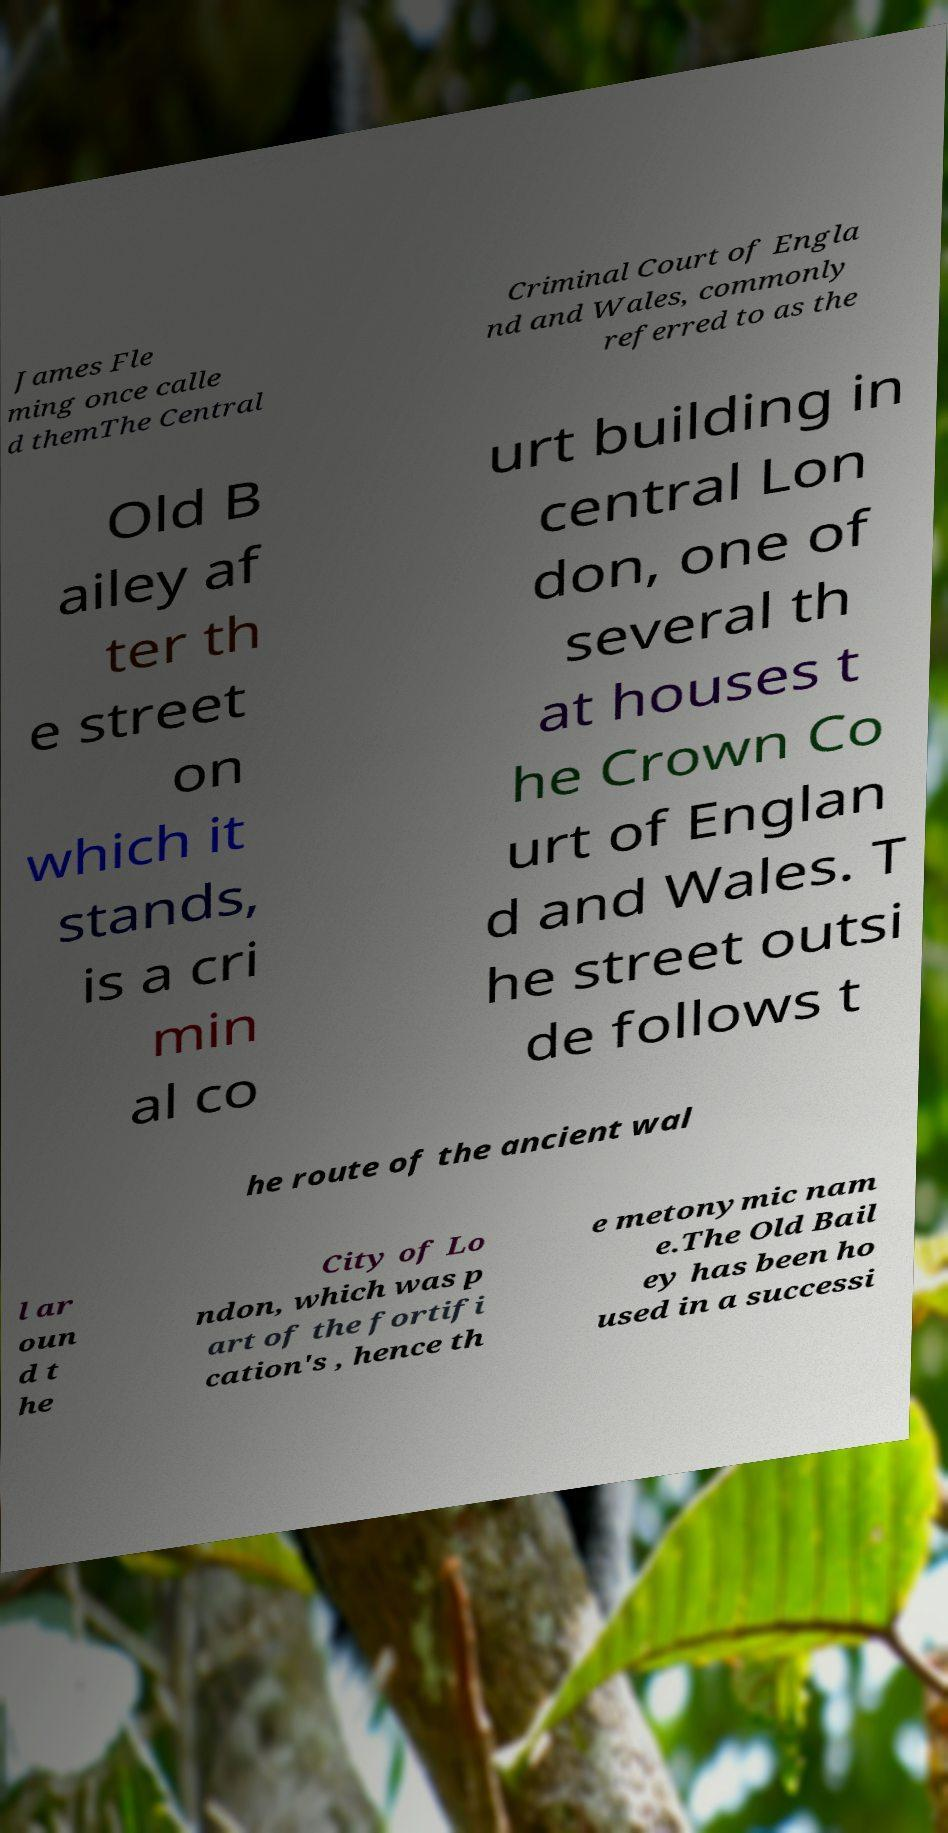I need the written content from this picture converted into text. Can you do that? James Fle ming once calle d themThe Central Criminal Court of Engla nd and Wales, commonly referred to as the Old B ailey af ter th e street on which it stands, is a cri min al co urt building in central Lon don, one of several th at houses t he Crown Co urt of Englan d and Wales. T he street outsi de follows t he route of the ancient wal l ar oun d t he City of Lo ndon, which was p art of the fortifi cation's , hence th e metonymic nam e.The Old Bail ey has been ho used in a successi 